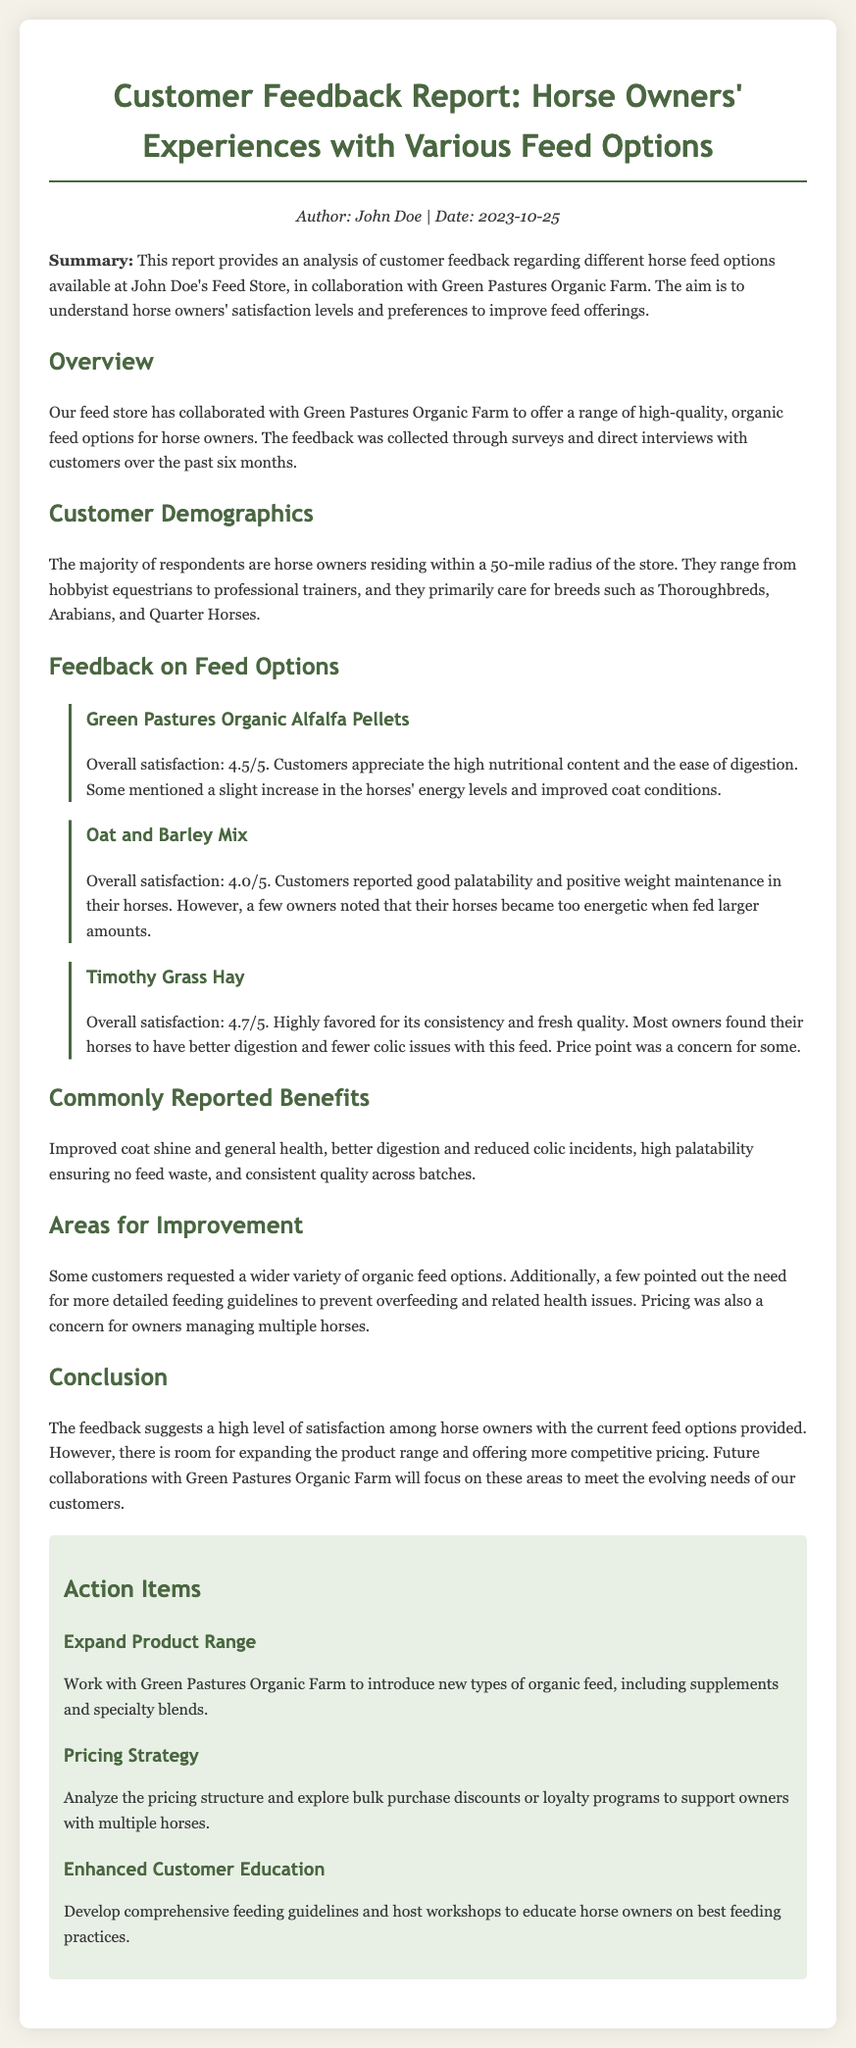what is the overall satisfaction rating for Green Pastures Organic Alfalfa Pellets? The overall satisfaction rating for Green Pastures Organic Alfalfa Pellets is stated in the feedback section of the document.
Answer: 4.5/5 what were the horse breeds mentioned by customers? The document specifies the breeds cared for by the horse owners in the customer demographics section.
Answer: Thoroughbreds, Arabians, Quarter Horses what is the satisfaction rating for Timothy Grass Hay? The satisfaction rating for Timothy Grass Hay is explicitly mentioned in the feedback section of the report.
Answer: 4.7/5 what common benefit is reported by customers regarding the feed? The document highlights several benefits reported by customers in the benefits section.
Answer: Improved coat shine what action item focuses on customer education? An action item is dedicated to improving customer education and is detailed under action items in the document.
Answer: Enhanced Customer Education how often was the customer feedback collected? The document provides a time frame for how long customer feedback was collected.
Answer: Six months what was a pricing concern noted by customers? The document mentions customer concerns regarding the pricing of the feed in the areas for improvement section.
Answer: Managing multiple horses which feed option had a reported issue with horses becoming too energetic? The feedback section discusses how certain feed options affected horse energy levels.
Answer: Oat and Barley Mix 